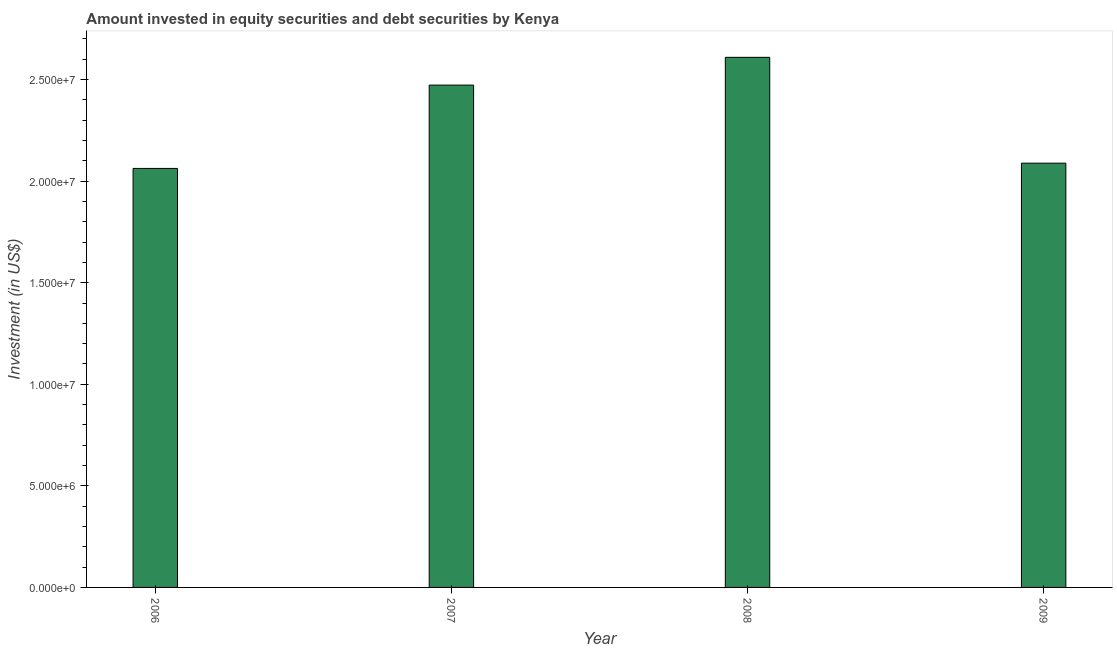Does the graph contain any zero values?
Your answer should be very brief. No. Does the graph contain grids?
Your answer should be compact. No. What is the title of the graph?
Keep it short and to the point. Amount invested in equity securities and debt securities by Kenya. What is the label or title of the Y-axis?
Your response must be concise. Investment (in US$). What is the portfolio investment in 2008?
Provide a short and direct response. 2.61e+07. Across all years, what is the maximum portfolio investment?
Your answer should be very brief. 2.61e+07. Across all years, what is the minimum portfolio investment?
Your response must be concise. 2.06e+07. What is the sum of the portfolio investment?
Your response must be concise. 9.23e+07. What is the difference between the portfolio investment in 2007 and 2009?
Give a very brief answer. 3.84e+06. What is the average portfolio investment per year?
Your answer should be very brief. 2.31e+07. What is the median portfolio investment?
Ensure brevity in your answer.  2.28e+07. Do a majority of the years between 2008 and 2007 (inclusive) have portfolio investment greater than 24000000 US$?
Provide a short and direct response. No. What is the ratio of the portfolio investment in 2006 to that in 2007?
Offer a very short reply. 0.83. Is the difference between the portfolio investment in 2006 and 2009 greater than the difference between any two years?
Ensure brevity in your answer.  No. What is the difference between the highest and the second highest portfolio investment?
Ensure brevity in your answer.  1.37e+06. What is the difference between the highest and the lowest portfolio investment?
Your answer should be compact. 5.47e+06. How many bars are there?
Your answer should be very brief. 4. Are all the bars in the graph horizontal?
Your answer should be compact. No. How many years are there in the graph?
Offer a very short reply. 4. What is the difference between two consecutive major ticks on the Y-axis?
Provide a succinct answer. 5.00e+06. Are the values on the major ticks of Y-axis written in scientific E-notation?
Provide a short and direct response. Yes. What is the Investment (in US$) in 2006?
Give a very brief answer. 2.06e+07. What is the Investment (in US$) of 2007?
Offer a very short reply. 2.47e+07. What is the Investment (in US$) of 2008?
Provide a succinct answer. 2.61e+07. What is the Investment (in US$) in 2009?
Ensure brevity in your answer.  2.09e+07. What is the difference between the Investment (in US$) in 2006 and 2007?
Give a very brief answer. -4.10e+06. What is the difference between the Investment (in US$) in 2006 and 2008?
Your response must be concise. -5.47e+06. What is the difference between the Investment (in US$) in 2006 and 2009?
Keep it short and to the point. -2.59e+05. What is the difference between the Investment (in US$) in 2007 and 2008?
Make the answer very short. -1.37e+06. What is the difference between the Investment (in US$) in 2007 and 2009?
Offer a terse response. 3.84e+06. What is the difference between the Investment (in US$) in 2008 and 2009?
Your answer should be compact. 5.21e+06. What is the ratio of the Investment (in US$) in 2006 to that in 2007?
Provide a short and direct response. 0.83. What is the ratio of the Investment (in US$) in 2006 to that in 2008?
Your response must be concise. 0.79. What is the ratio of the Investment (in US$) in 2007 to that in 2008?
Make the answer very short. 0.95. What is the ratio of the Investment (in US$) in 2007 to that in 2009?
Give a very brief answer. 1.18. What is the ratio of the Investment (in US$) in 2008 to that in 2009?
Keep it short and to the point. 1.25. 